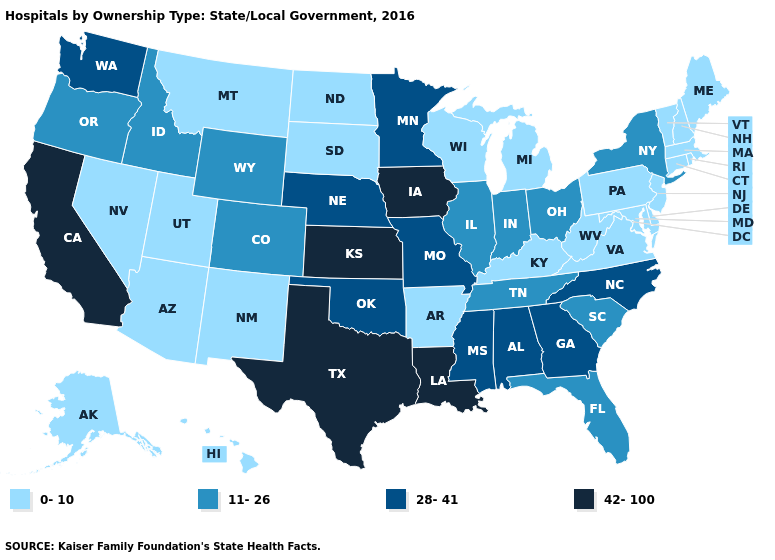What is the lowest value in states that border Ohio?
Write a very short answer. 0-10. Name the states that have a value in the range 28-41?
Write a very short answer. Alabama, Georgia, Minnesota, Mississippi, Missouri, Nebraska, North Carolina, Oklahoma, Washington. Is the legend a continuous bar?
Concise answer only. No. Does Iowa have the highest value in the USA?
Short answer required. Yes. What is the value of Nevada?
Quick response, please. 0-10. Name the states that have a value in the range 11-26?
Write a very short answer. Colorado, Florida, Idaho, Illinois, Indiana, New York, Ohio, Oregon, South Carolina, Tennessee, Wyoming. Does the map have missing data?
Be succinct. No. What is the lowest value in states that border Wisconsin?
Short answer required. 0-10. Does Oregon have the lowest value in the West?
Give a very brief answer. No. Name the states that have a value in the range 42-100?
Give a very brief answer. California, Iowa, Kansas, Louisiana, Texas. Name the states that have a value in the range 28-41?
Write a very short answer. Alabama, Georgia, Minnesota, Mississippi, Missouri, Nebraska, North Carolina, Oklahoma, Washington. Which states have the lowest value in the USA?
Answer briefly. Alaska, Arizona, Arkansas, Connecticut, Delaware, Hawaii, Kentucky, Maine, Maryland, Massachusetts, Michigan, Montana, Nevada, New Hampshire, New Jersey, New Mexico, North Dakota, Pennsylvania, Rhode Island, South Dakota, Utah, Vermont, Virginia, West Virginia, Wisconsin. Does Oklahoma have the same value as Alabama?
Keep it brief. Yes. What is the value of Rhode Island?
Answer briefly. 0-10. Name the states that have a value in the range 28-41?
Give a very brief answer. Alabama, Georgia, Minnesota, Mississippi, Missouri, Nebraska, North Carolina, Oklahoma, Washington. 